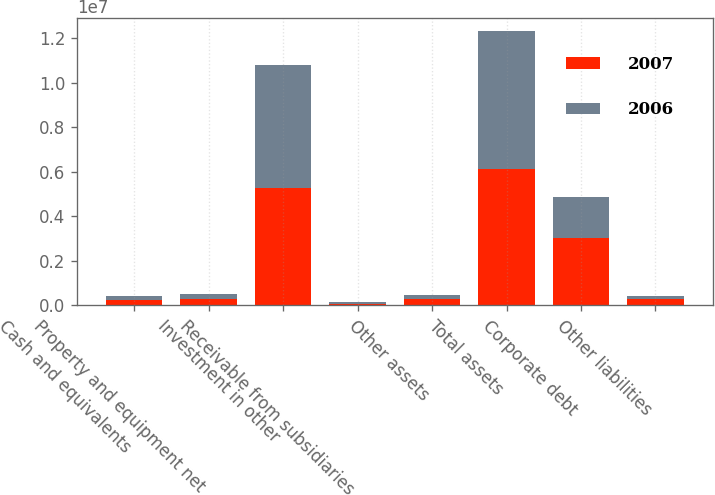Convert chart to OTSL. <chart><loc_0><loc_0><loc_500><loc_500><stacked_bar_chart><ecel><fcel>Cash and equivalents<fcel>Property and equipment net<fcel>Investment in other<fcel>Receivable from subsidiaries<fcel>Other assets<fcel>Total assets<fcel>Corporate debt<fcel>Other liabilities<nl><fcel>2007<fcel>251663<fcel>273894<fcel>5.28742e+06<fcel>35544<fcel>259997<fcel>6.10852e+06<fcel>3.0227e+06<fcel>256758<nl><fcel>2006<fcel>139542<fcel>230120<fcel>5.52901e+06<fcel>107031<fcel>201495<fcel>6.2072e+06<fcel>1.84217e+06<fcel>168656<nl></chart> 